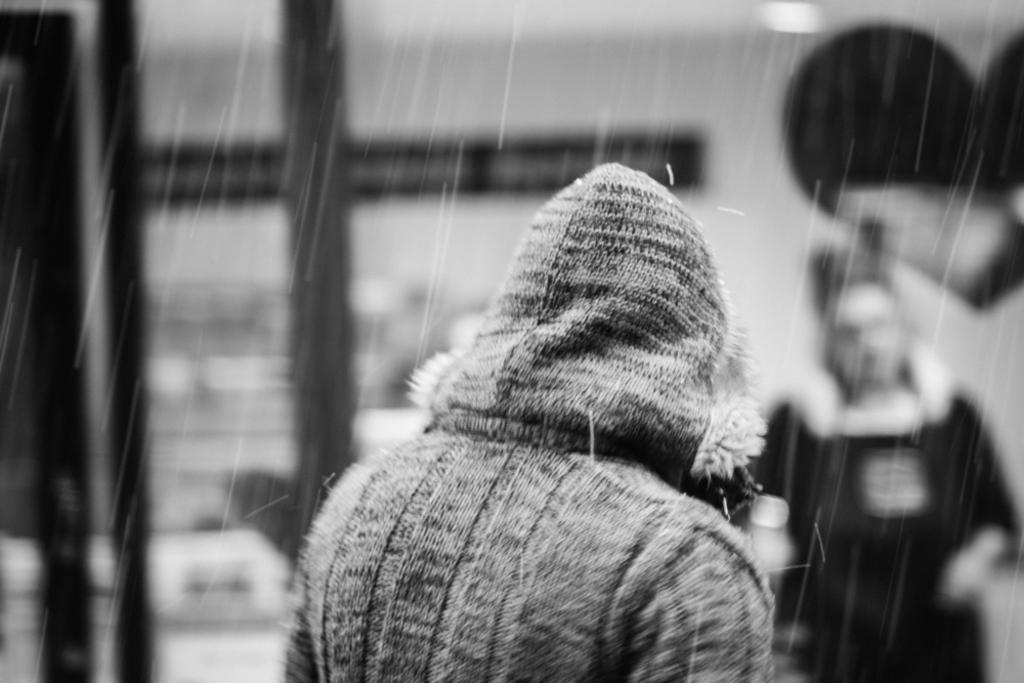In one or two sentences, can you explain what this image depicts? This image consists of a person wearing a jacket. It looks like it is raining. In the background, there is a person. And the background is blurred. 